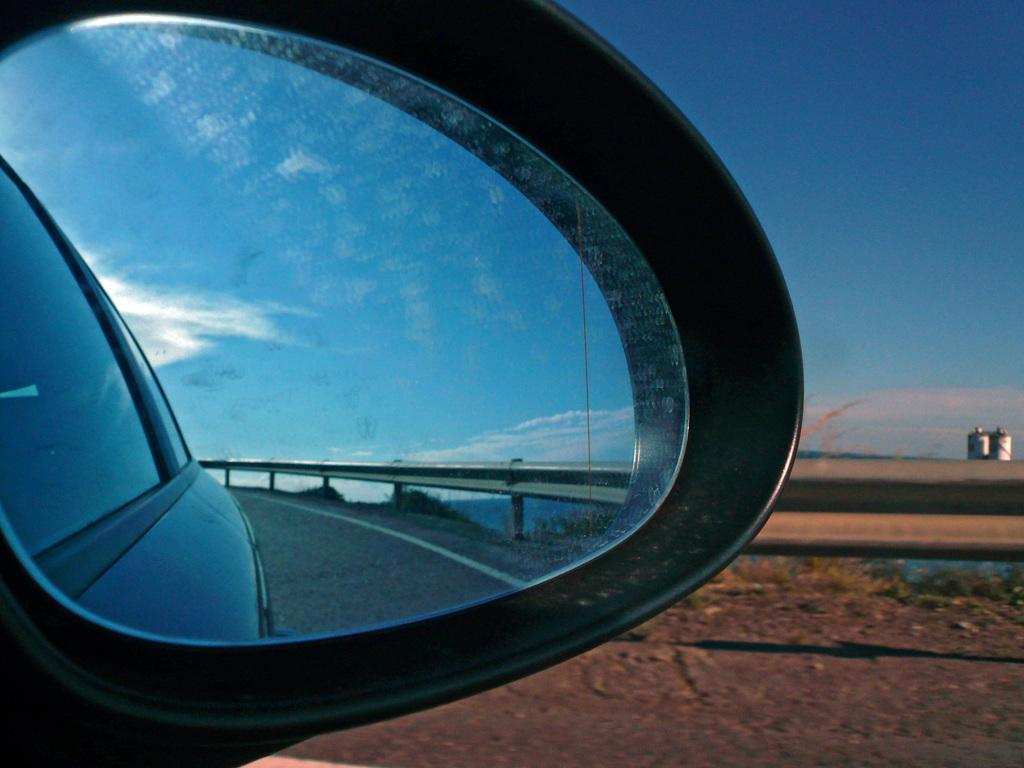Where was the picture taken? The picture was taken on a road. What can be seen on the left side of the image? There is a car on the left side of the image. What object in the image allows for reflection? The image contains a mirror. What type of line or barrier is visible in the image? The image shows a boundary. How would you describe the weather based on the image? The sky is cloudy in the image. What type of vegetation is present on the ground in the image? There are plants on the ground in the image. What type of quilt is being used to create harmony in the image? There is no quilt or reference to harmony in the image; it features a road, a car, a mirror, a boundary, a cloudy sky, and plants. 